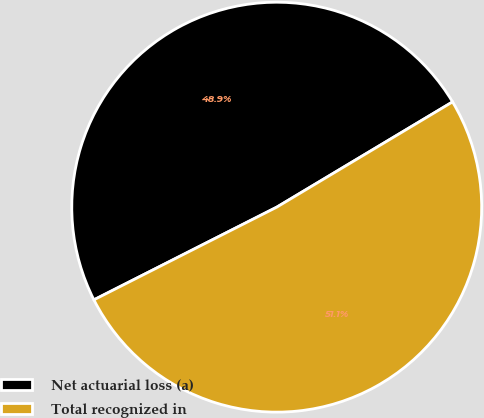Convert chart to OTSL. <chart><loc_0><loc_0><loc_500><loc_500><pie_chart><fcel>Net actuarial loss (a)<fcel>Total recognized in<nl><fcel>48.88%<fcel>51.12%<nl></chart> 